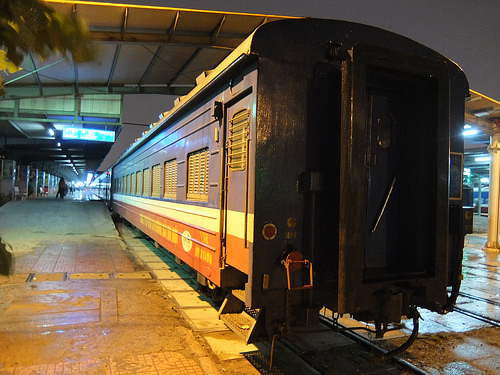<image>
Is there a train behind the station? No. The train is not behind the station. From this viewpoint, the train appears to be positioned elsewhere in the scene. 